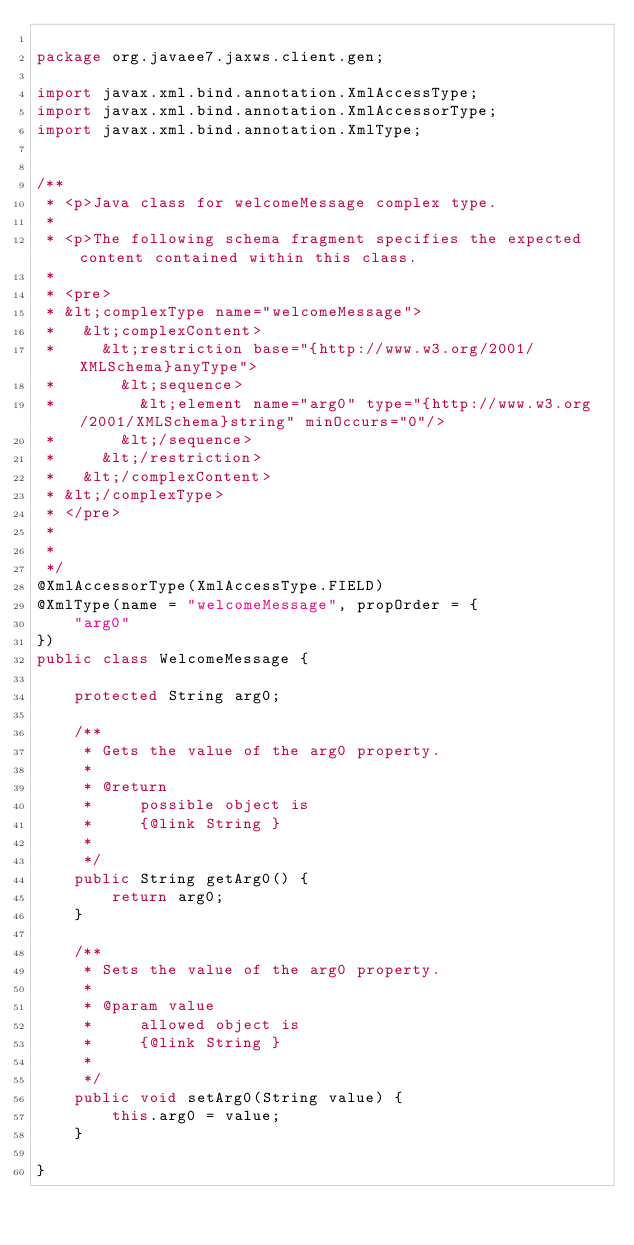<code> <loc_0><loc_0><loc_500><loc_500><_Java_>
package org.javaee7.jaxws.client.gen;

import javax.xml.bind.annotation.XmlAccessType;
import javax.xml.bind.annotation.XmlAccessorType;
import javax.xml.bind.annotation.XmlType;


/**
 * <p>Java class for welcomeMessage complex type.
 * 
 * <p>The following schema fragment specifies the expected content contained within this class.
 * 
 * <pre>
 * &lt;complexType name="welcomeMessage">
 *   &lt;complexContent>
 *     &lt;restriction base="{http://www.w3.org/2001/XMLSchema}anyType">
 *       &lt;sequence>
 *         &lt;element name="arg0" type="{http://www.w3.org/2001/XMLSchema}string" minOccurs="0"/>
 *       &lt;/sequence>
 *     &lt;/restriction>
 *   &lt;/complexContent>
 * &lt;/complexType>
 * </pre>
 * 
 * 
 */
@XmlAccessorType(XmlAccessType.FIELD)
@XmlType(name = "welcomeMessage", propOrder = {
    "arg0"
})
public class WelcomeMessage {

    protected String arg0;

    /**
     * Gets the value of the arg0 property.
     * 
     * @return
     *     possible object is
     *     {@link String }
     *     
     */
    public String getArg0() {
        return arg0;
    }

    /**
     * Sets the value of the arg0 property.
     * 
     * @param value
     *     allowed object is
     *     {@link String }
     *     
     */
    public void setArg0(String value) {
        this.arg0 = value;
    }

}
</code> 